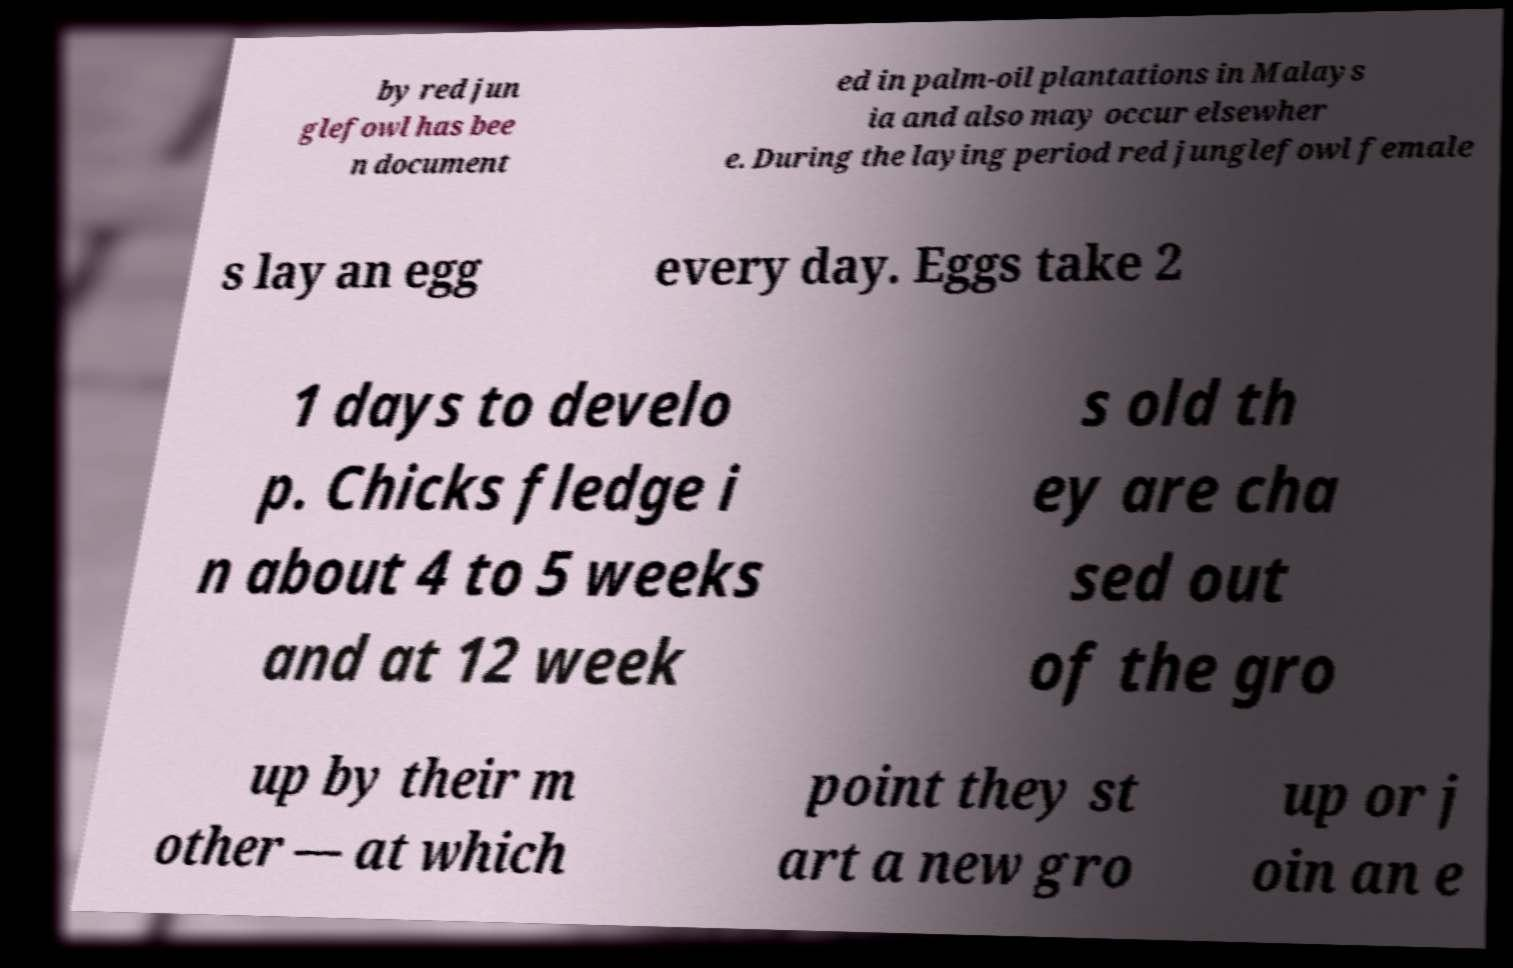Could you assist in decoding the text presented in this image and type it out clearly? by red jun glefowl has bee n document ed in palm-oil plantations in Malays ia and also may occur elsewher e. During the laying period red junglefowl female s lay an egg every day. Eggs take 2 1 days to develo p. Chicks fledge i n about 4 to 5 weeks and at 12 week s old th ey are cha sed out of the gro up by their m other — at which point they st art a new gro up or j oin an e 